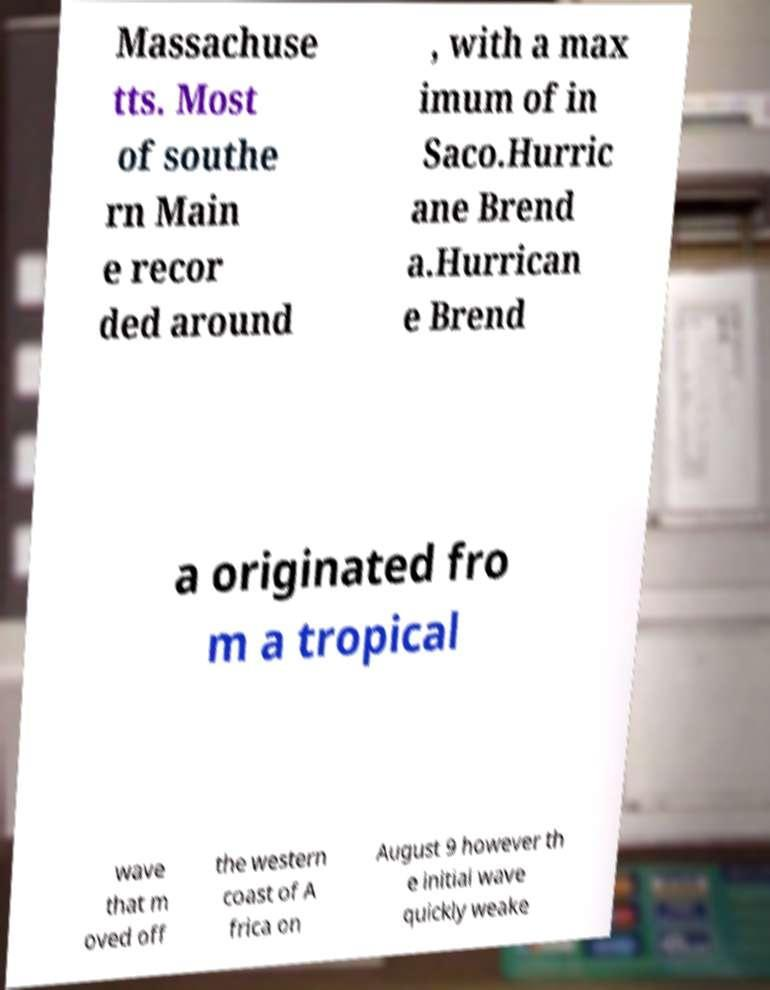What messages or text are displayed in this image? I need them in a readable, typed format. Massachuse tts. Most of southe rn Main e recor ded around , with a max imum of in Saco.Hurric ane Brend a.Hurrican e Brend a originated fro m a tropical wave that m oved off the western coast of A frica on August 9 however th e initial wave quickly weake 